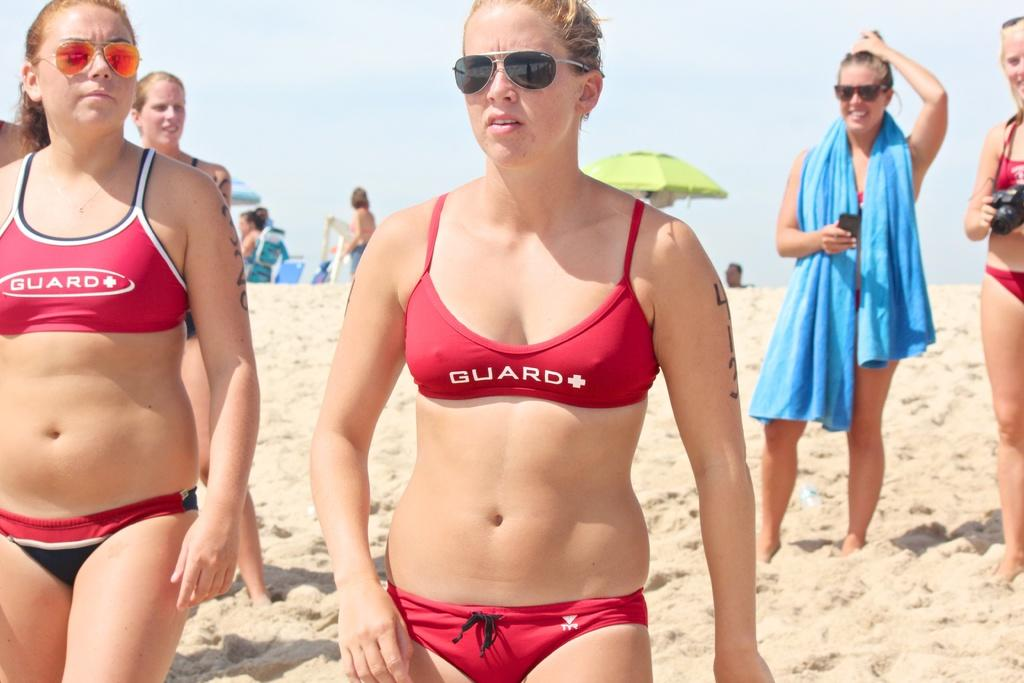<image>
Create a compact narrative representing the image presented. Woman wearing a red bathing suit that says "GUARD" on it. 